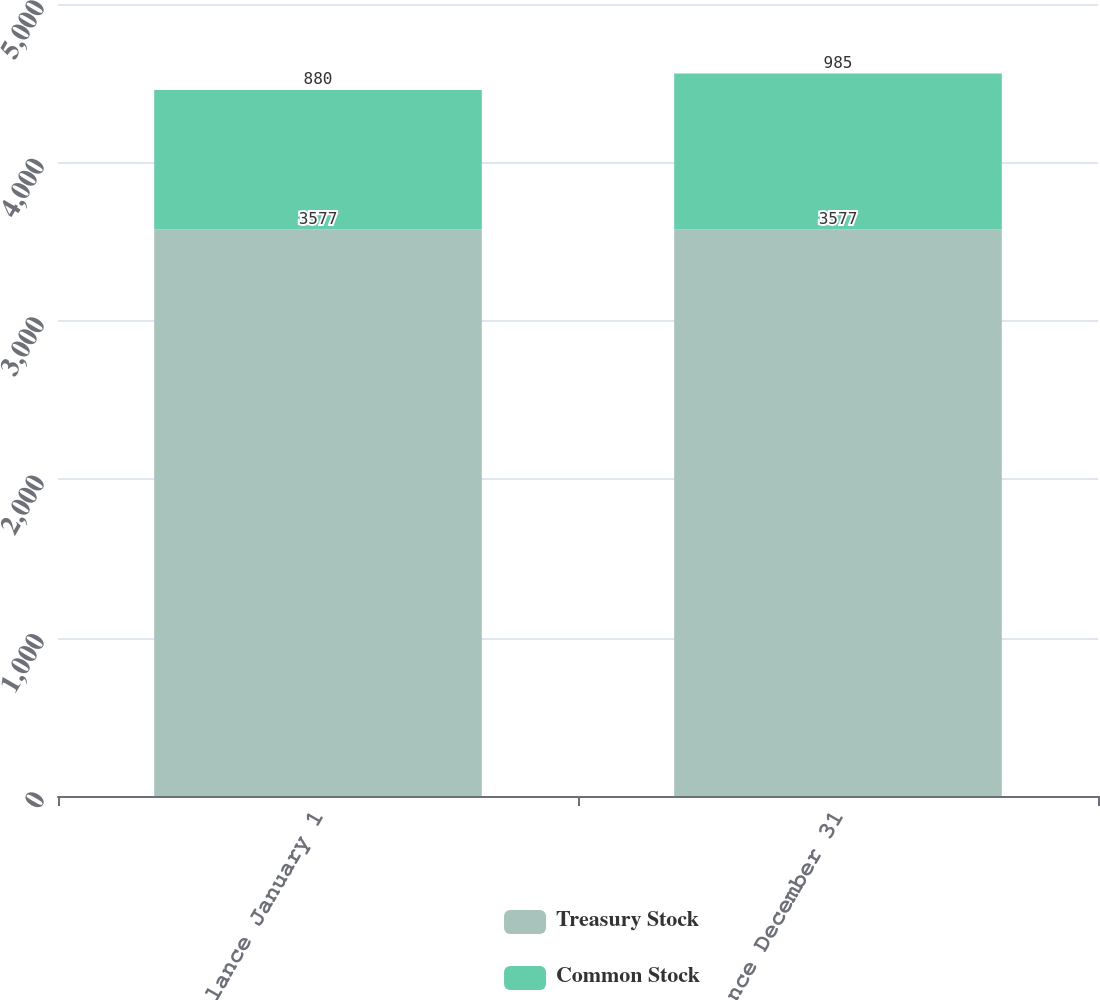<chart> <loc_0><loc_0><loc_500><loc_500><stacked_bar_chart><ecel><fcel>Balance January 1<fcel>Balance December 31<nl><fcel>Treasury Stock<fcel>3577<fcel>3577<nl><fcel>Common Stock<fcel>880<fcel>985<nl></chart> 